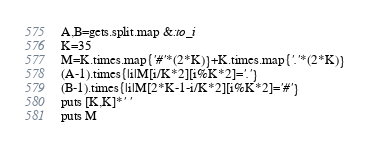Convert code to text. <code><loc_0><loc_0><loc_500><loc_500><_Ruby_>A,B=gets.split.map &:to_i
K=35
M=K.times.map{'#'*(2*K)}+K.times.map{'.'*(2*K)}
(A-1).times{|i|M[i/K*2][i%K*2]='.'}
(B-1).times{|i|M[2*K-1-i/K*2][i%K*2]='#'}
puts [K,K]*' '
puts M</code> 